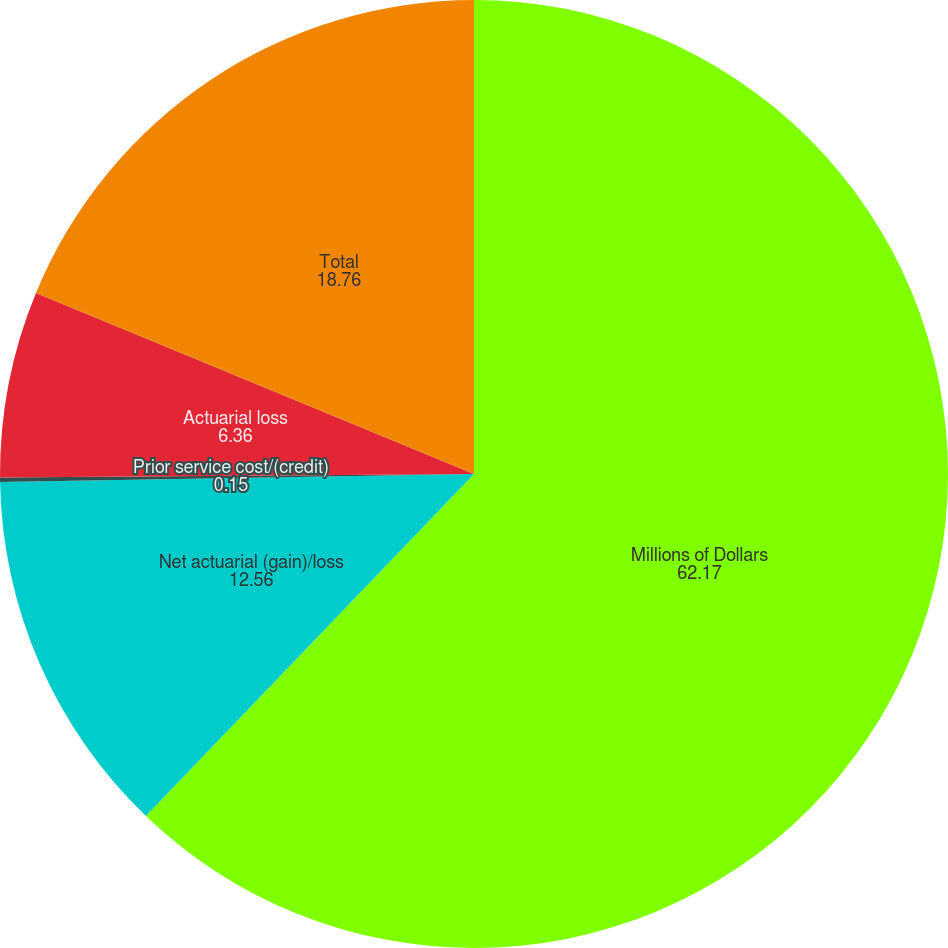Convert chart to OTSL. <chart><loc_0><loc_0><loc_500><loc_500><pie_chart><fcel>Millions of Dollars<fcel>Net actuarial (gain)/loss<fcel>Prior service cost/(credit)<fcel>Actuarial loss<fcel>Total<nl><fcel>62.17%<fcel>12.56%<fcel>0.15%<fcel>6.36%<fcel>18.76%<nl></chart> 